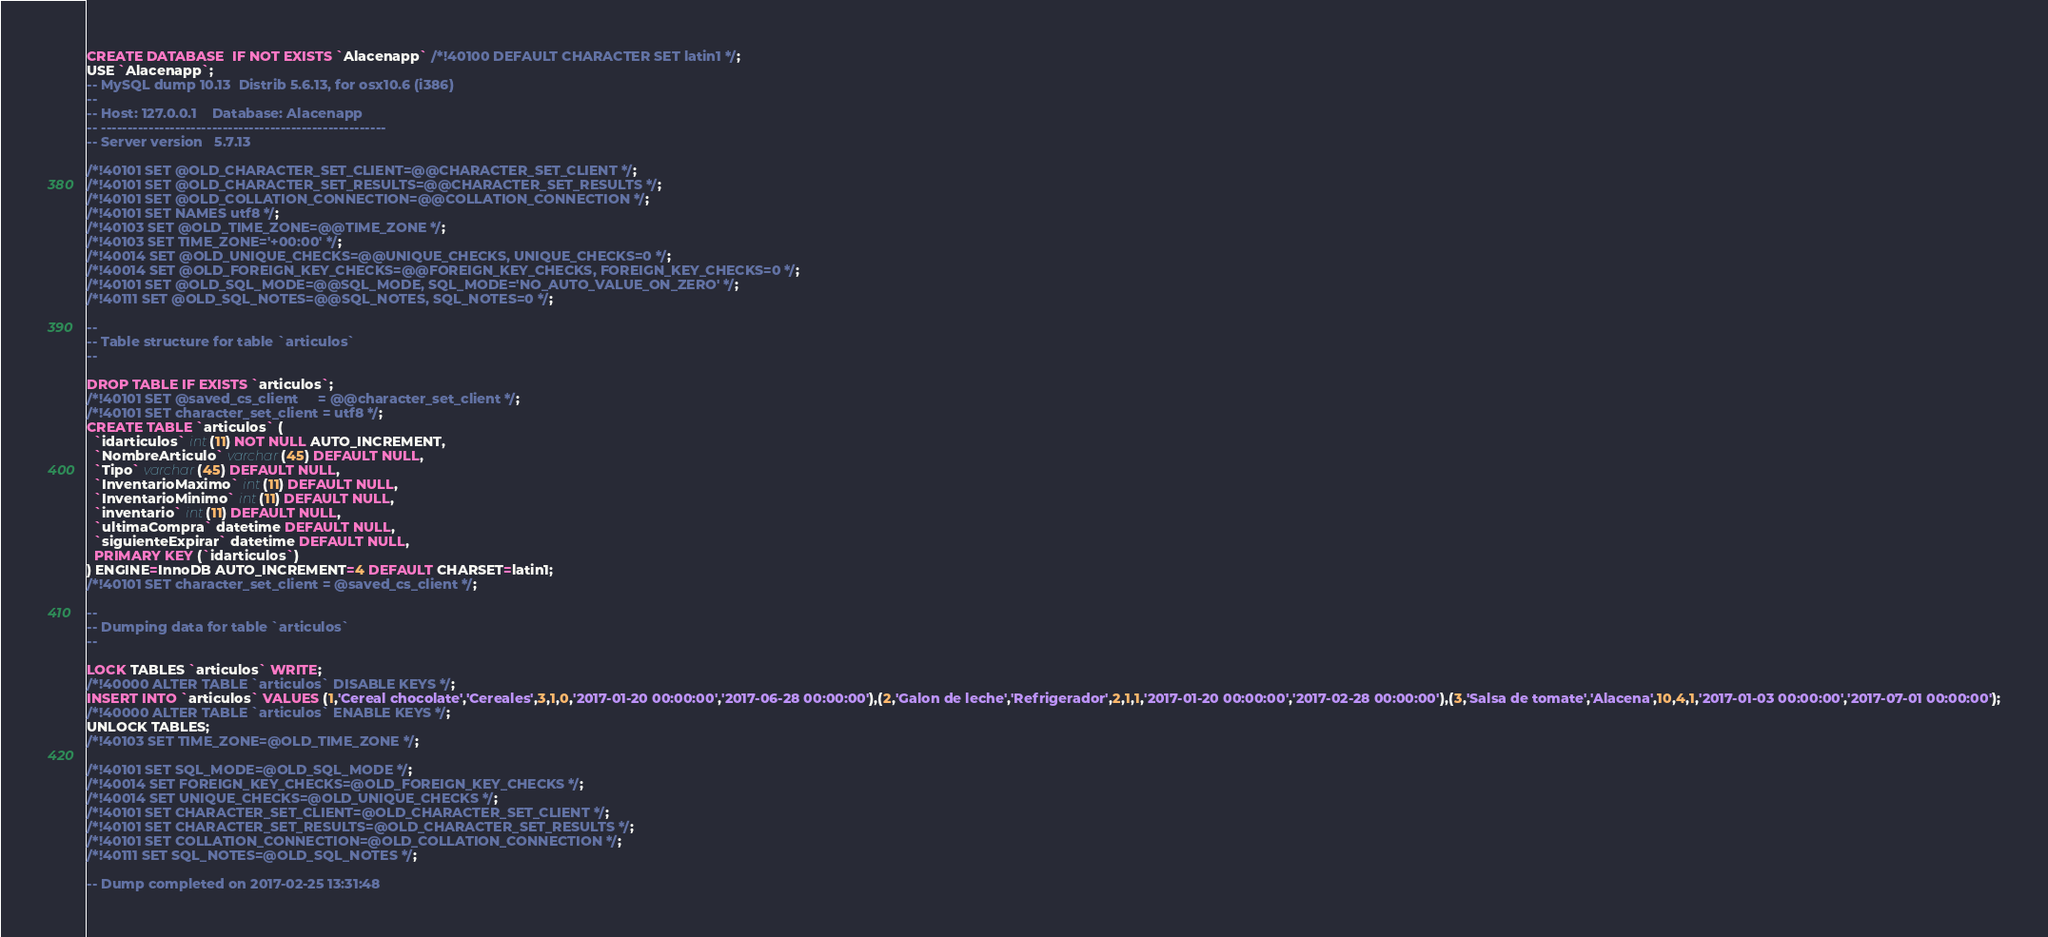Convert code to text. <code><loc_0><loc_0><loc_500><loc_500><_SQL_>CREATE DATABASE  IF NOT EXISTS `Alacenapp` /*!40100 DEFAULT CHARACTER SET latin1 */;
USE `Alacenapp`;
-- MySQL dump 10.13  Distrib 5.6.13, for osx10.6 (i386)
--
-- Host: 127.0.0.1    Database: Alacenapp
-- ------------------------------------------------------
-- Server version	5.7.13

/*!40101 SET @OLD_CHARACTER_SET_CLIENT=@@CHARACTER_SET_CLIENT */;
/*!40101 SET @OLD_CHARACTER_SET_RESULTS=@@CHARACTER_SET_RESULTS */;
/*!40101 SET @OLD_COLLATION_CONNECTION=@@COLLATION_CONNECTION */;
/*!40101 SET NAMES utf8 */;
/*!40103 SET @OLD_TIME_ZONE=@@TIME_ZONE */;
/*!40103 SET TIME_ZONE='+00:00' */;
/*!40014 SET @OLD_UNIQUE_CHECKS=@@UNIQUE_CHECKS, UNIQUE_CHECKS=0 */;
/*!40014 SET @OLD_FOREIGN_KEY_CHECKS=@@FOREIGN_KEY_CHECKS, FOREIGN_KEY_CHECKS=0 */;
/*!40101 SET @OLD_SQL_MODE=@@SQL_MODE, SQL_MODE='NO_AUTO_VALUE_ON_ZERO' */;
/*!40111 SET @OLD_SQL_NOTES=@@SQL_NOTES, SQL_NOTES=0 */;

--
-- Table structure for table `articulos`
--

DROP TABLE IF EXISTS `articulos`;
/*!40101 SET @saved_cs_client     = @@character_set_client */;
/*!40101 SET character_set_client = utf8 */;
CREATE TABLE `articulos` (
  `idarticulos` int(11) NOT NULL AUTO_INCREMENT,
  `NombreArticulo` varchar(45) DEFAULT NULL,
  `Tipo` varchar(45) DEFAULT NULL,
  `InventarioMaximo` int(11) DEFAULT NULL,
  `InventarioMinimo` int(11) DEFAULT NULL,
  `inventario` int(11) DEFAULT NULL,
  `ultimaCompra` datetime DEFAULT NULL,
  `siguienteExpirar` datetime DEFAULT NULL,
  PRIMARY KEY (`idarticulos`)
) ENGINE=InnoDB AUTO_INCREMENT=4 DEFAULT CHARSET=latin1;
/*!40101 SET character_set_client = @saved_cs_client */;

--
-- Dumping data for table `articulos`
--

LOCK TABLES `articulos` WRITE;
/*!40000 ALTER TABLE `articulos` DISABLE KEYS */;
INSERT INTO `articulos` VALUES (1,'Cereal chocolate','Cereales',3,1,0,'2017-01-20 00:00:00','2017-06-28 00:00:00'),(2,'Galon de leche','Refrigerador',2,1,1,'2017-01-20 00:00:00','2017-02-28 00:00:00'),(3,'Salsa de tomate','Alacena',10,4,1,'2017-01-03 00:00:00','2017-07-01 00:00:00');
/*!40000 ALTER TABLE `articulos` ENABLE KEYS */;
UNLOCK TABLES;
/*!40103 SET TIME_ZONE=@OLD_TIME_ZONE */;

/*!40101 SET SQL_MODE=@OLD_SQL_MODE */;
/*!40014 SET FOREIGN_KEY_CHECKS=@OLD_FOREIGN_KEY_CHECKS */;
/*!40014 SET UNIQUE_CHECKS=@OLD_UNIQUE_CHECKS */;
/*!40101 SET CHARACTER_SET_CLIENT=@OLD_CHARACTER_SET_CLIENT */;
/*!40101 SET CHARACTER_SET_RESULTS=@OLD_CHARACTER_SET_RESULTS */;
/*!40101 SET COLLATION_CONNECTION=@OLD_COLLATION_CONNECTION */;
/*!40111 SET SQL_NOTES=@OLD_SQL_NOTES */;

-- Dump completed on 2017-02-25 13:31:48
</code> 